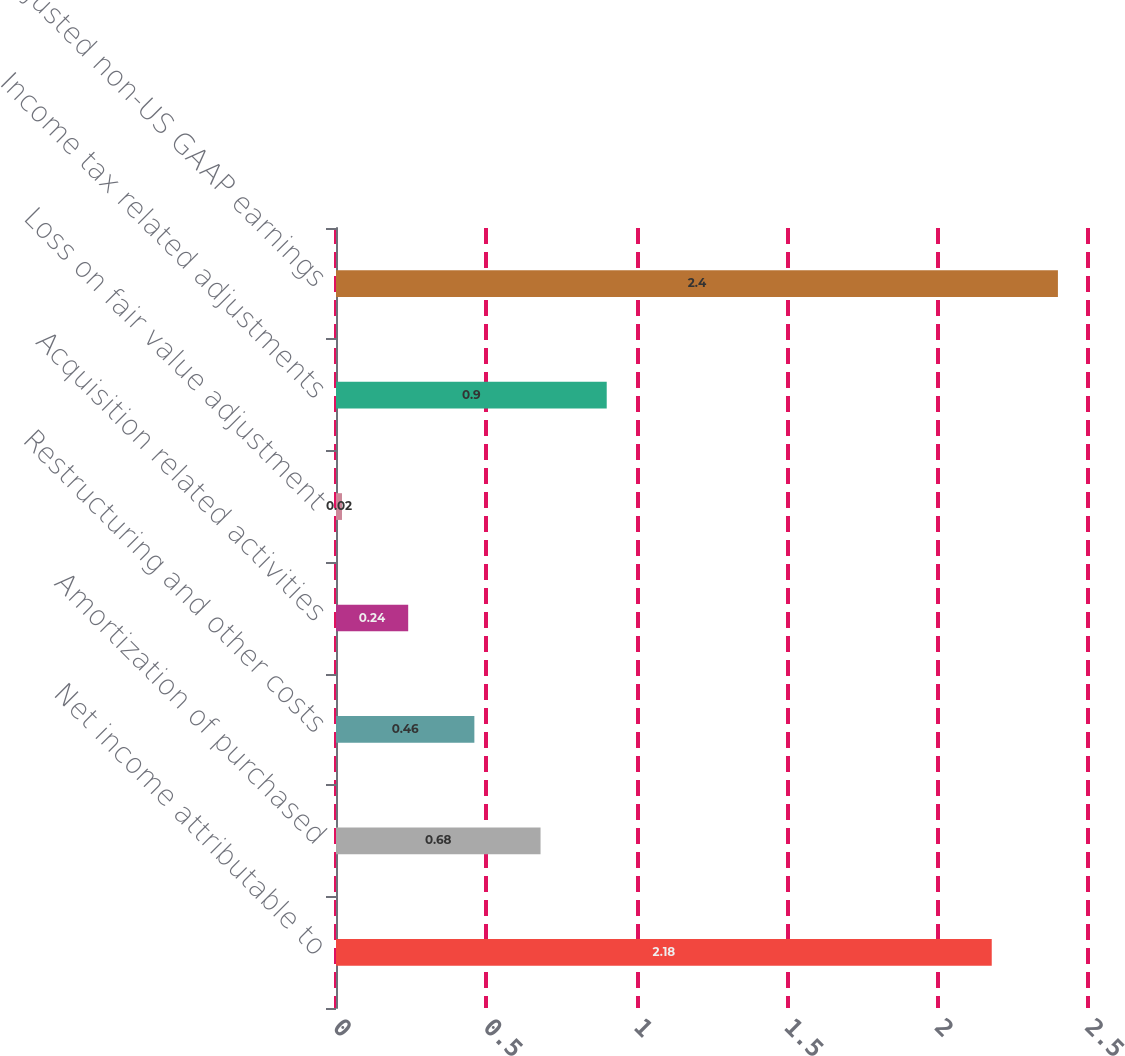Convert chart to OTSL. <chart><loc_0><loc_0><loc_500><loc_500><bar_chart><fcel>Net income attributable to<fcel>Amortization of purchased<fcel>Restructuring and other costs<fcel>Acquisition related activities<fcel>Loss on fair value adjustment<fcel>Income tax related adjustments<fcel>Adjusted non-US GAAP earnings<nl><fcel>2.18<fcel>0.68<fcel>0.46<fcel>0.24<fcel>0.02<fcel>0.9<fcel>2.4<nl></chart> 